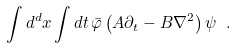Convert formula to latex. <formula><loc_0><loc_0><loc_500><loc_500>\int d ^ { d } x \int d t \, \bar { \varphi } \left ( A \partial _ { t } - B \nabla ^ { 2 } \right ) \psi \ .</formula> 